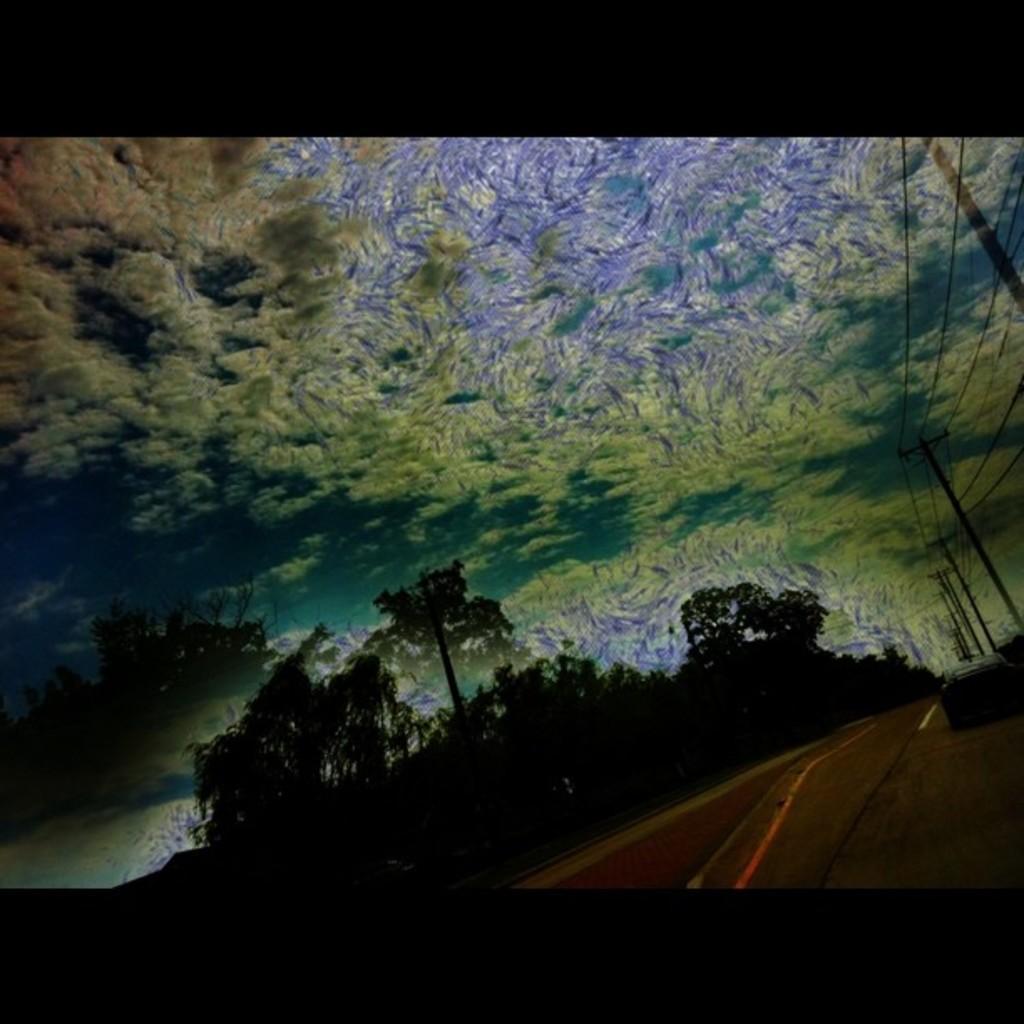Please provide a concise description of this image. This is an edited image, in this image there are trees, road, poles and the sky. 